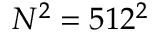<formula> <loc_0><loc_0><loc_500><loc_500>N ^ { 2 } = 5 1 2 ^ { 2 }</formula> 